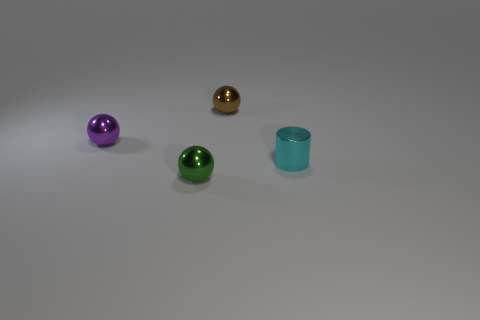What is the size of the metallic thing left of the small green sphere?
Provide a short and direct response. Small. Is there anything else that has the same color as the cylinder?
Your response must be concise. No. What is the shape of the tiny cyan object that is the same material as the small green sphere?
Keep it short and to the point. Cylinder. Does the tiny thing in front of the small cyan metallic cylinder have the same material as the cyan object?
Your response must be concise. Yes. How many small things are behind the green metal ball and to the left of the brown object?
Provide a short and direct response. 1. There is a purple metal object that is the same size as the cyan object; what shape is it?
Keep it short and to the point. Sphere. What number of large blue metallic balls are there?
Provide a short and direct response. 0. What number of tiny cyan objects are the same shape as the small green thing?
Ensure brevity in your answer.  0. Is the shape of the brown thing the same as the purple shiny thing?
Your response must be concise. Yes. The purple metal object has what size?
Offer a terse response. Small. 